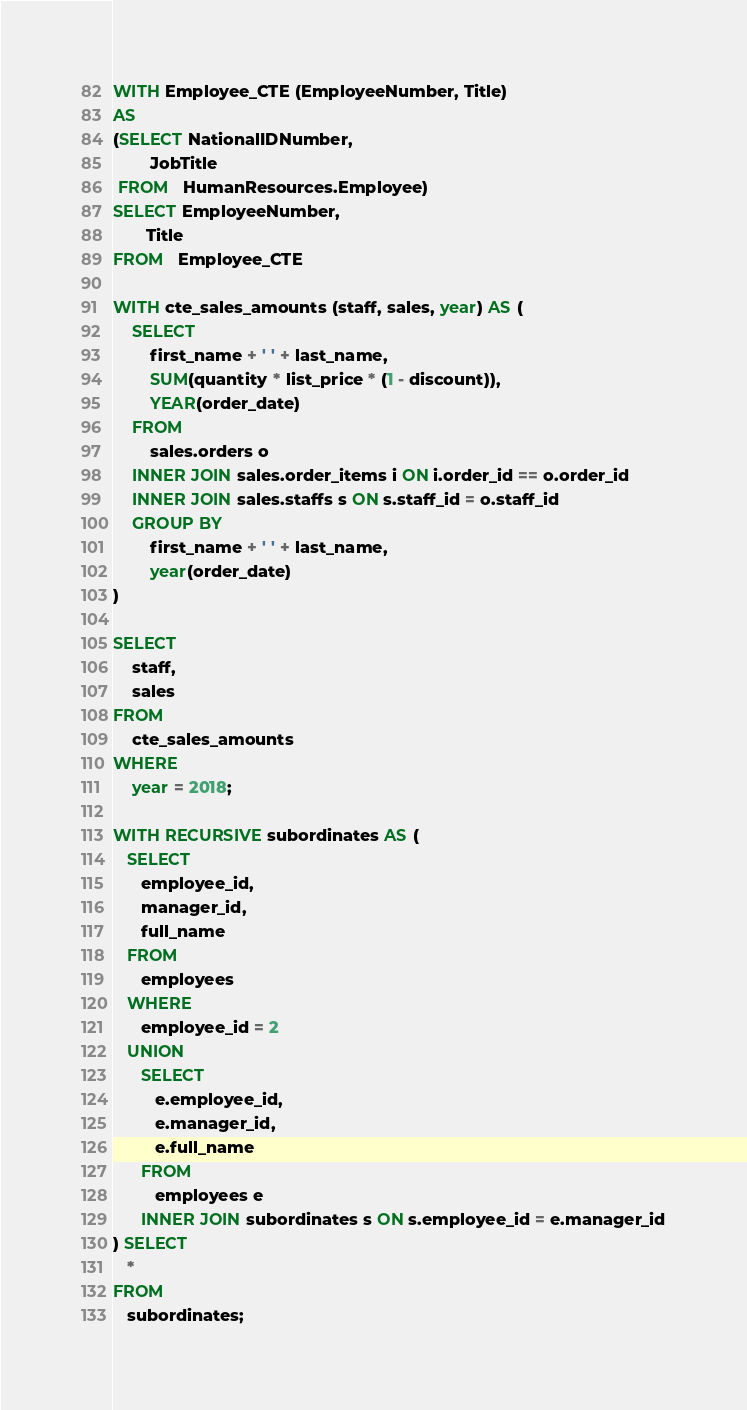<code> <loc_0><loc_0><loc_500><loc_500><_SQL_>WITH Employee_CTE (EmployeeNumber, Title)
AS
(SELECT NationalIDNumber,
        JobTitle
 FROM   HumanResources.Employee)
SELECT EmployeeNumber,
       Title
FROM   Employee_CTE

WITH cte_sales_amounts (staff, sales, year) AS (
    SELECT    
        first_name + ' ' + last_name, 
        SUM(quantity * list_price * (1 - discount)),
        YEAR(order_date)
    FROM    
        sales.orders o
    INNER JOIN sales.order_items i ON i.order_id == o.order_id
    INNER JOIN sales.staffs s ON s.staff_id = o.staff_id
    GROUP BY 
        first_name + ' ' + last_name,
        year(order_date)
)
 
SELECT
    staff, 
    sales
FROM 
    cte_sales_amounts
WHERE
    year = 2018;

WITH RECURSIVE subordinates AS (
   SELECT
      employee_id,
      manager_id,
      full_name
   FROM
      employees
   WHERE
      employee_id = 2
   UNION
      SELECT
         e.employee_id,
         e.manager_id,
         e.full_name
      FROM
         employees e
      INNER JOIN subordinates s ON s.employee_id = e.manager_id
) SELECT
   *
FROM
   subordinates;
</code> 